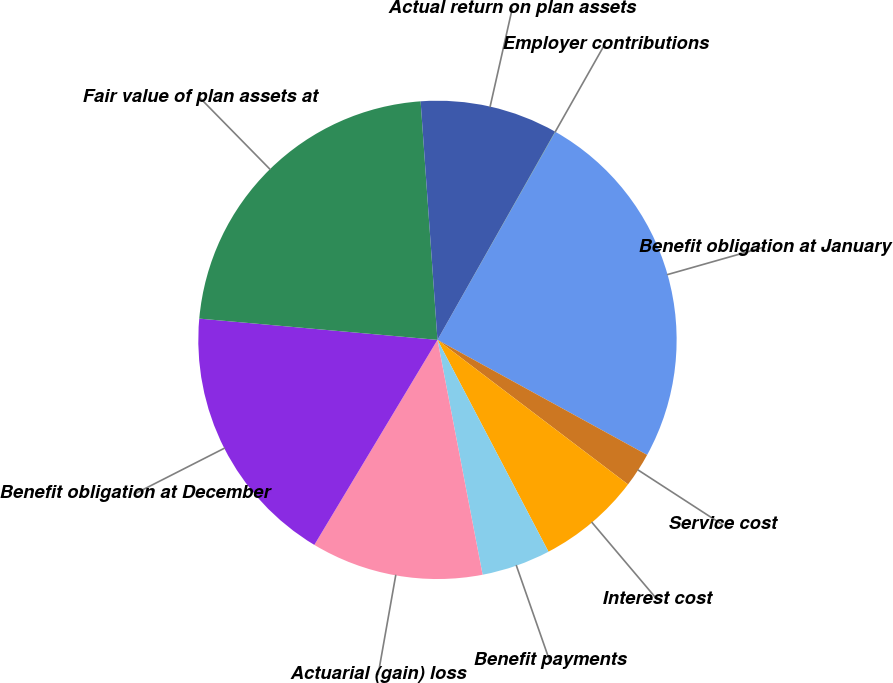Convert chart to OTSL. <chart><loc_0><loc_0><loc_500><loc_500><pie_chart><fcel>Benefit obligation at January<fcel>Service cost<fcel>Interest cost<fcel>Benefit payments<fcel>Actuarial (gain) loss<fcel>Benefit obligation at December<fcel>Fair value of plan assets at<fcel>Actual return on plan assets<fcel>Employer contributions<nl><fcel>24.78%<fcel>2.34%<fcel>6.99%<fcel>4.66%<fcel>11.63%<fcel>17.81%<fcel>22.46%<fcel>9.31%<fcel>0.02%<nl></chart> 